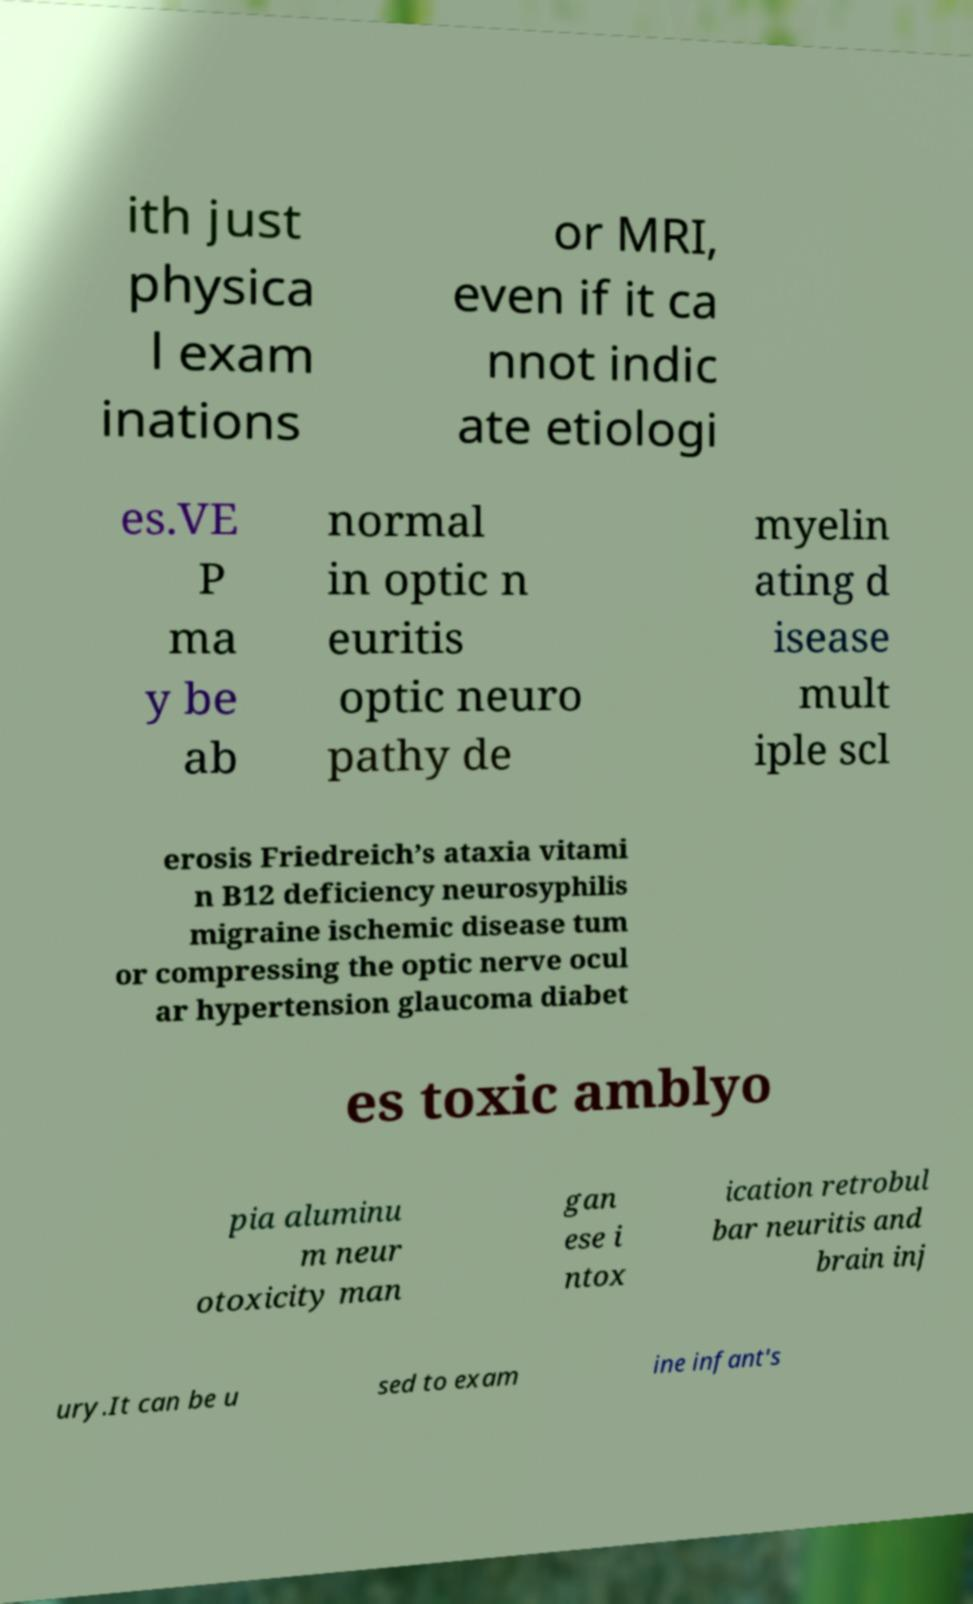For documentation purposes, I need the text within this image transcribed. Could you provide that? ith just physica l exam inations or MRI, even if it ca nnot indic ate etiologi es.VE P ma y be ab normal in optic n euritis optic neuro pathy de myelin ating d isease mult iple scl erosis Friedreich’s ataxia vitami n B12 deficiency neurosyphilis migraine ischemic disease tum or compressing the optic nerve ocul ar hypertension glaucoma diabet es toxic amblyo pia aluminu m neur otoxicity man gan ese i ntox ication retrobul bar neuritis and brain inj ury.It can be u sed to exam ine infant's 